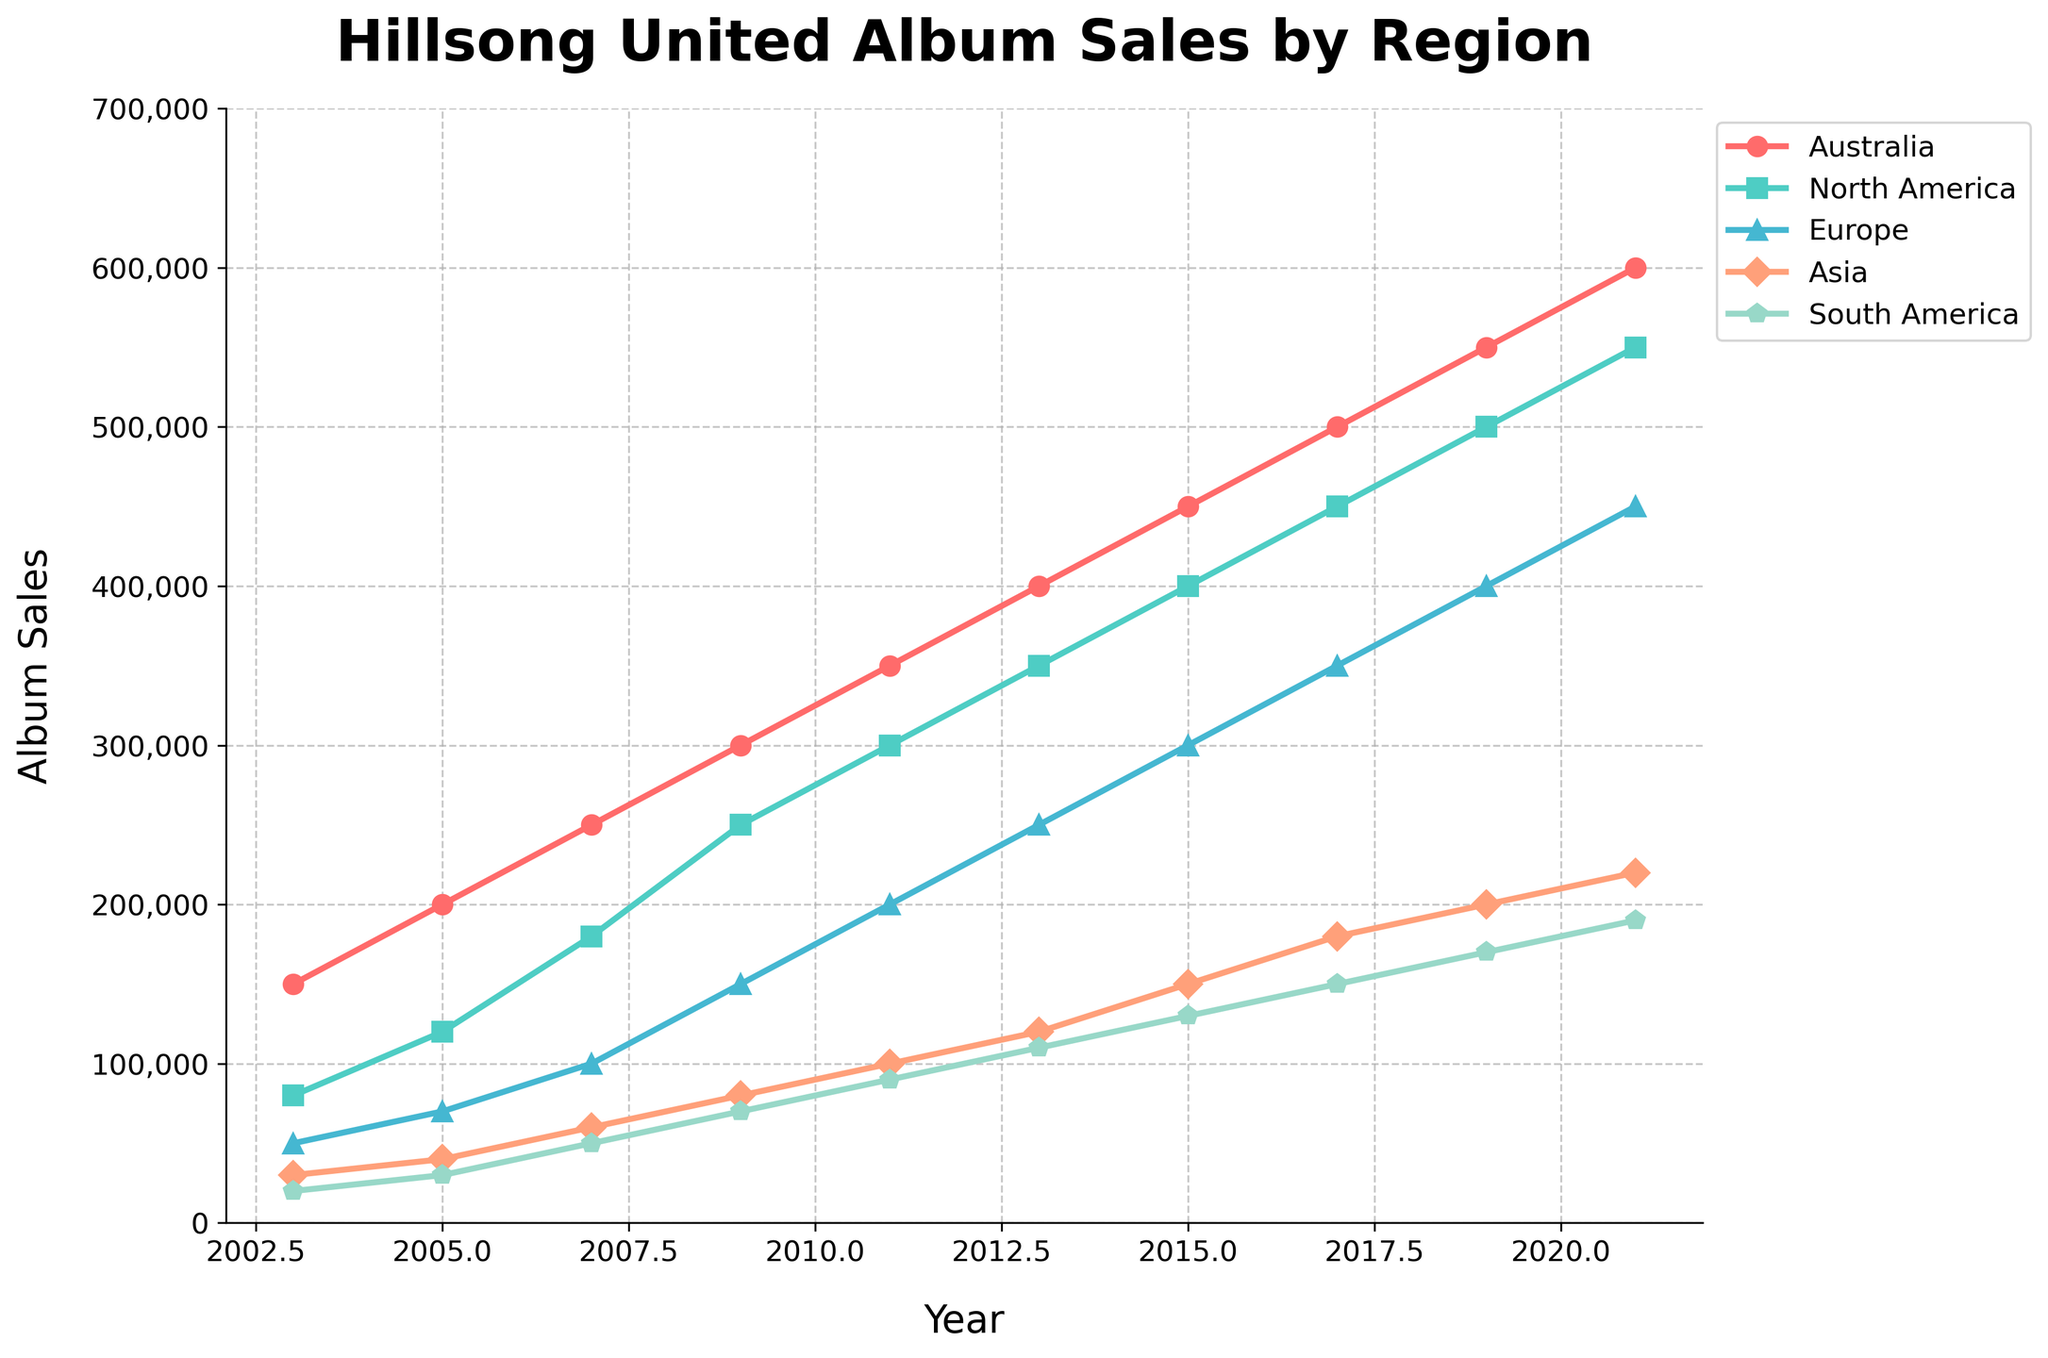What year did Hillsong United album sales in Australia surpass 500,000? Looking at the line representing Australia, we see it touches 500,000 in 2017 and surpasses it in 2019.
Answer: 2019 Which region had the second highest album sales in 2009? In 2009, the top sales were in Australia at 300,000. The second-highest region is North America with 250,000.
Answer: North America In which year did album sales in South America reach 150,000? Observing the line for South America, it reaches 150,000 in 2017.
Answer: 2017 By how much did sales increase in Europe from 2005 to 2009? In 2005, Europe had 70,000 in sales and increased to 150,000 by 2009. The increase is 150,000 - 70,000 = 80,000.
Answer: 80,000 In which years did the album sales in Asia surpass those in South America? Reviewing the lines for Asia and South America, Asia surpasses South America in 2015, 2017, 2019, and 2021.
Answer: 2015, 2017, 2019, 2021 What was the average album sales in North America over the decade 2003-2013? Adding North American sales from 2003 to 2013 (80,000 + 120,000 + 180,000 + 250,000 + 300,000 + 350,000) and dividing by the 6 data points: (80,000 + 120,000 + 180,000 + 250,000 + 300,000 + 350,000) / 6 = 1,280,000 / 6 ≈ 213,333.
Answer: 213,333 Which region saw the smallest growth from 2019 to 2021? Growth from 2019 to 2021: Australia: 600,000 - 550,000 = 50,000, North America: 550,000 - 500,000 = 50,000, Europe: 450,000 - 400,000 = 50,000, Asia: 220,000 - 200,000 = 20,000, South America: 190,000 - 170,000 = 20,000. Ties are Asia and South America with a growth of 20,000 each.
Answer: Asia and South America Was there a period when sales in Europe caught up with sales in North America? The lines for North America and Europe never intersect or touch, with North America consistently above Europe, so Europe never caught up.
Answer: No By how much did album sales grow in Australia from 2003 to 2021? Album sales in Australia started at 150,000 in 2003 and grew to 600,000 by 2021. The growth is 600,000 - 150,000 = 450,000.
Answer: 450,000 Compare the sales trends in Asia and South America from 2003 to 2021. Both Asia and South America show a steady increase, Asia grows from 30,000 to 220,000, and South America from 20,000 to 190,000. Asia consistently remains above South America, indicating higher growth in Asia over the period.
Answer: Asia higher growth 